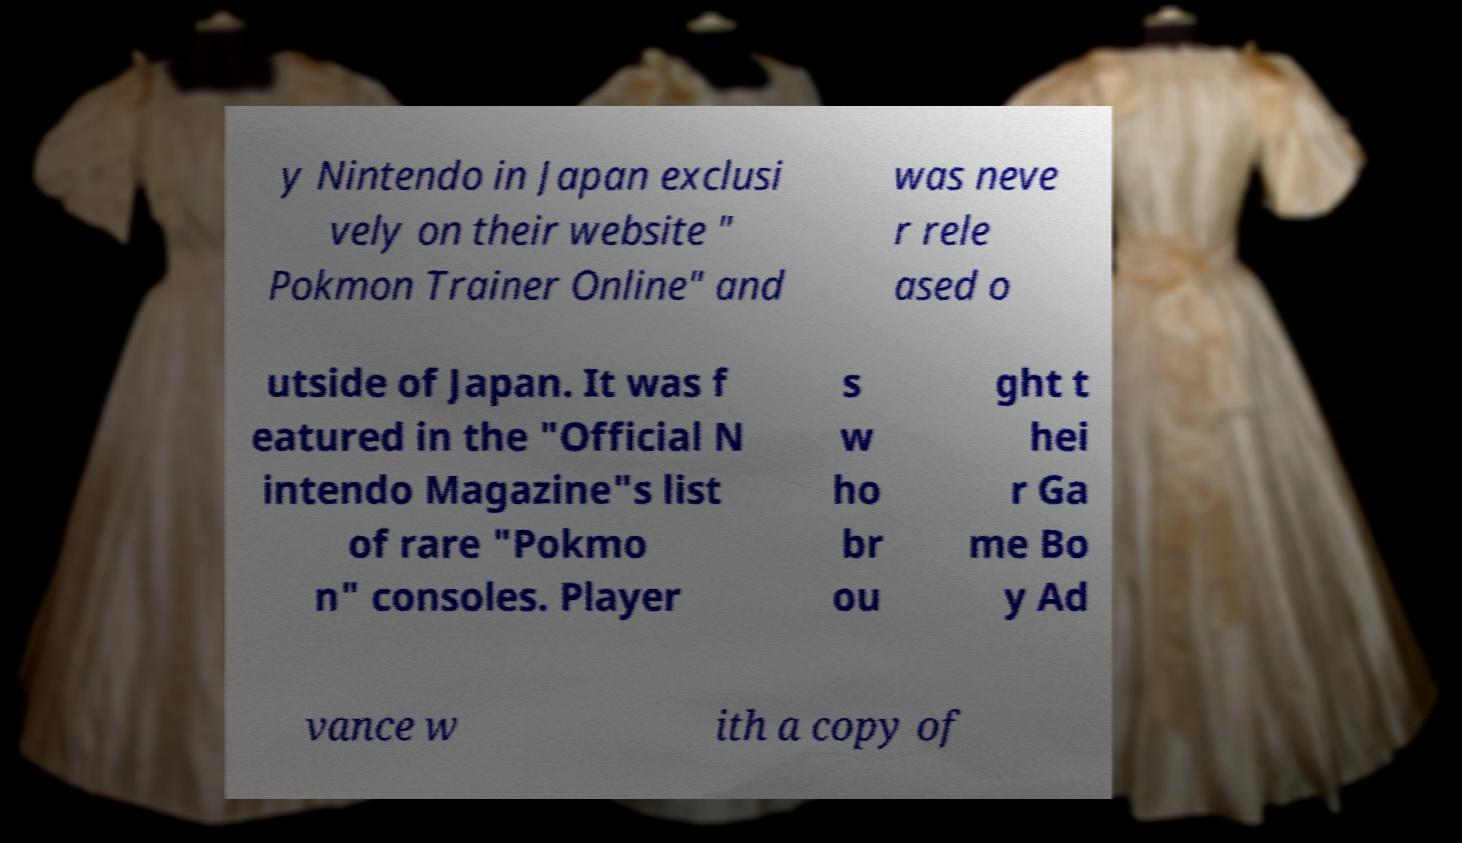There's text embedded in this image that I need extracted. Can you transcribe it verbatim? y Nintendo in Japan exclusi vely on their website " Pokmon Trainer Online" and was neve r rele ased o utside of Japan. It was f eatured in the "Official N intendo Magazine"s list of rare "Pokmo n" consoles. Player s w ho br ou ght t hei r Ga me Bo y Ad vance w ith a copy of 